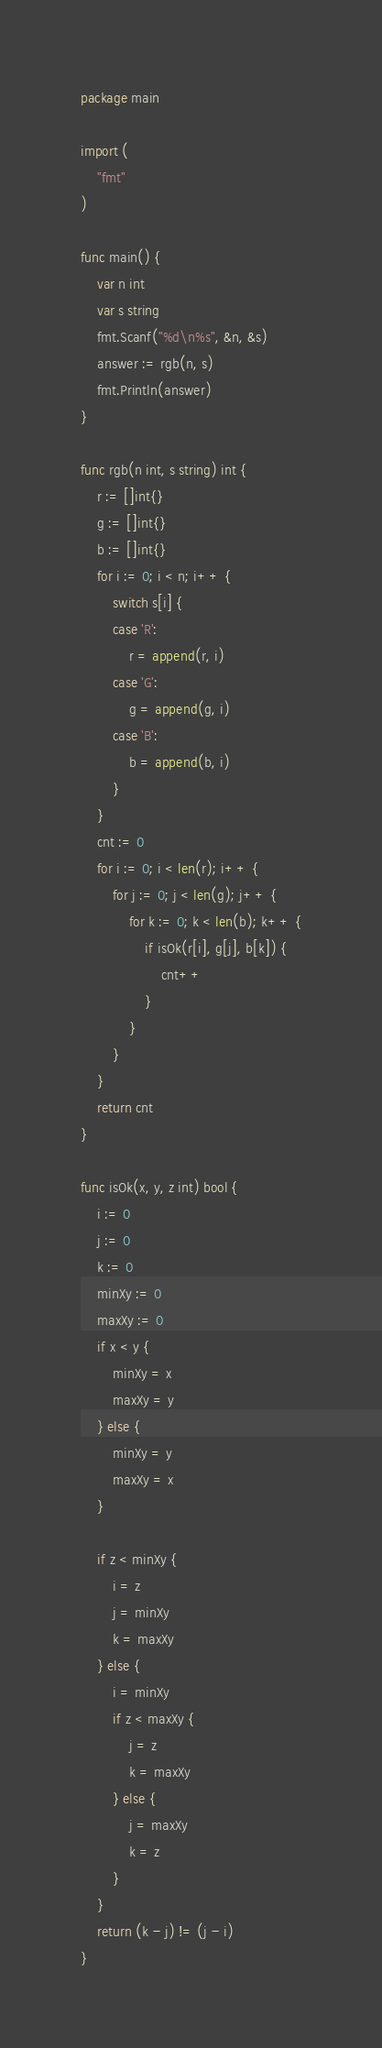<code> <loc_0><loc_0><loc_500><loc_500><_Go_>package main

import (
	"fmt"
)

func main() {
	var n int
	var s string
	fmt.Scanf("%d\n%s", &n, &s)
	answer := rgb(n, s)
	fmt.Println(answer)
}

func rgb(n int, s string) int {
	r := []int{}
	g := []int{}
	b := []int{}
	for i := 0; i < n; i++ {
		switch s[i] {
		case 'R':
			r = append(r, i)
		case 'G':
			g = append(g, i)
		case 'B':
			b = append(b, i)
		}
	}
	cnt := 0
	for i := 0; i < len(r); i++ {
		for j := 0; j < len(g); j++ {
			for k := 0; k < len(b); k++ {
				if isOk(r[i], g[j], b[k]) {
					cnt++
				}
			}
		}
	}
	return cnt
}

func isOk(x, y, z int) bool {
	i := 0
	j := 0
	k := 0
	minXy := 0
	maxXy := 0
	if x < y {
		minXy = x
		maxXy = y
	} else {
		minXy = y
		maxXy = x
	}

	if z < minXy {
		i = z
		j = minXy
		k = maxXy
	} else {
		i = minXy
		if z < maxXy {
			j = z
			k = maxXy
		} else {
			j = maxXy
			k = z
		}
	}
	return (k - j) != (j - i)
}
</code> 